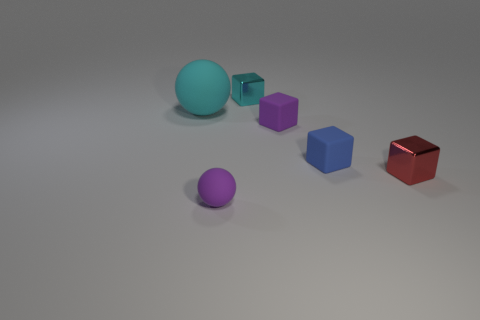There is a object that is the same color as the small ball; what is its material?
Ensure brevity in your answer.  Rubber. Are there any metallic objects?
Keep it short and to the point. Yes. There is a purple object that is the same shape as the tiny cyan object; what material is it?
Give a very brief answer. Rubber. Are there any small objects to the right of the blue rubber object?
Give a very brief answer. Yes. Is the tiny purple thing behind the small red shiny block made of the same material as the cyan cube?
Provide a succinct answer. No. Is there a tiny shiny object of the same color as the big matte ball?
Your response must be concise. Yes. What is the shape of the small cyan metal thing?
Ensure brevity in your answer.  Cube. There is a small metal object that is to the right of the blue object that is right of the cyan sphere; what is its color?
Ensure brevity in your answer.  Red. There is a ball that is behind the small purple ball; what size is it?
Ensure brevity in your answer.  Large. Are there any big cyan objects that have the same material as the small blue object?
Make the answer very short. Yes. 